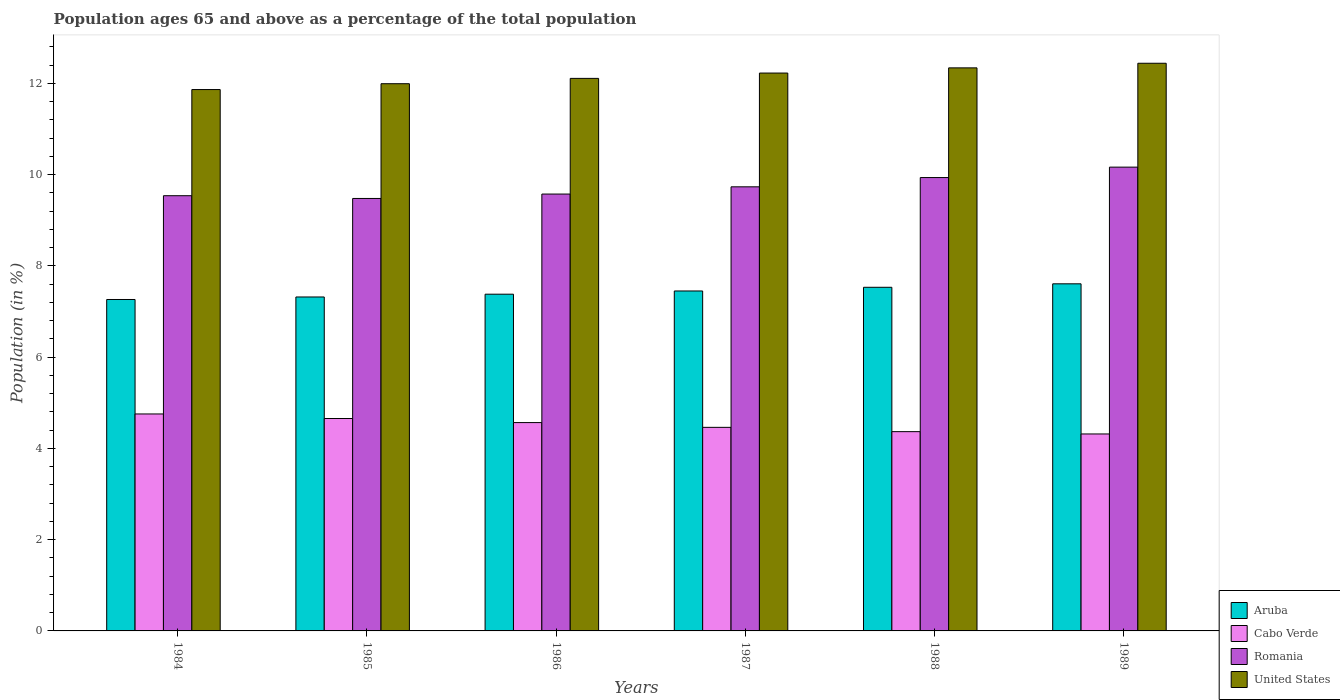How many groups of bars are there?
Your answer should be very brief. 6. Are the number of bars per tick equal to the number of legend labels?
Your answer should be very brief. Yes. What is the label of the 1st group of bars from the left?
Ensure brevity in your answer.  1984. What is the percentage of the population ages 65 and above in Romania in 1989?
Give a very brief answer. 10.16. Across all years, what is the maximum percentage of the population ages 65 and above in Romania?
Your answer should be compact. 10.16. Across all years, what is the minimum percentage of the population ages 65 and above in Aruba?
Offer a very short reply. 7.26. In which year was the percentage of the population ages 65 and above in United States maximum?
Ensure brevity in your answer.  1989. What is the total percentage of the population ages 65 and above in Cabo Verde in the graph?
Provide a short and direct response. 27.12. What is the difference between the percentage of the population ages 65 and above in Aruba in 1987 and that in 1988?
Your answer should be very brief. -0.08. What is the difference between the percentage of the population ages 65 and above in United States in 1986 and the percentage of the population ages 65 and above in Romania in 1985?
Keep it short and to the point. 2.63. What is the average percentage of the population ages 65 and above in Romania per year?
Your answer should be compact. 9.74. In the year 1989, what is the difference between the percentage of the population ages 65 and above in Aruba and percentage of the population ages 65 and above in Romania?
Give a very brief answer. -2.56. What is the ratio of the percentage of the population ages 65 and above in Cabo Verde in 1985 to that in 1986?
Give a very brief answer. 1.02. Is the percentage of the population ages 65 and above in Aruba in 1984 less than that in 1986?
Provide a short and direct response. Yes. Is the difference between the percentage of the population ages 65 and above in Aruba in 1988 and 1989 greater than the difference between the percentage of the population ages 65 and above in Romania in 1988 and 1989?
Keep it short and to the point. Yes. What is the difference between the highest and the second highest percentage of the population ages 65 and above in Cabo Verde?
Keep it short and to the point. 0.1. What is the difference between the highest and the lowest percentage of the population ages 65 and above in Cabo Verde?
Keep it short and to the point. 0.44. In how many years, is the percentage of the population ages 65 and above in Romania greater than the average percentage of the population ages 65 and above in Romania taken over all years?
Your response must be concise. 2. Is the sum of the percentage of the population ages 65 and above in Aruba in 1984 and 1987 greater than the maximum percentage of the population ages 65 and above in Cabo Verde across all years?
Offer a very short reply. Yes. What does the 2nd bar from the left in 1988 represents?
Your answer should be very brief. Cabo Verde. What does the 2nd bar from the right in 1985 represents?
Keep it short and to the point. Romania. How many bars are there?
Keep it short and to the point. 24. Are all the bars in the graph horizontal?
Make the answer very short. No. What is the difference between two consecutive major ticks on the Y-axis?
Ensure brevity in your answer.  2. Does the graph contain any zero values?
Give a very brief answer. No. What is the title of the graph?
Make the answer very short. Population ages 65 and above as a percentage of the total population. Does "Germany" appear as one of the legend labels in the graph?
Give a very brief answer. No. What is the Population (in %) in Aruba in 1984?
Make the answer very short. 7.26. What is the Population (in %) of Cabo Verde in 1984?
Your response must be concise. 4.75. What is the Population (in %) of Romania in 1984?
Make the answer very short. 9.54. What is the Population (in %) of United States in 1984?
Your answer should be compact. 11.86. What is the Population (in %) in Aruba in 1985?
Offer a very short reply. 7.32. What is the Population (in %) of Cabo Verde in 1985?
Ensure brevity in your answer.  4.65. What is the Population (in %) in Romania in 1985?
Offer a very short reply. 9.48. What is the Population (in %) in United States in 1985?
Offer a terse response. 11.99. What is the Population (in %) in Aruba in 1986?
Your response must be concise. 7.38. What is the Population (in %) of Cabo Verde in 1986?
Ensure brevity in your answer.  4.57. What is the Population (in %) in Romania in 1986?
Keep it short and to the point. 9.57. What is the Population (in %) of United States in 1986?
Make the answer very short. 12.11. What is the Population (in %) in Aruba in 1987?
Provide a short and direct response. 7.45. What is the Population (in %) of Cabo Verde in 1987?
Provide a short and direct response. 4.46. What is the Population (in %) of Romania in 1987?
Provide a succinct answer. 9.73. What is the Population (in %) in United States in 1987?
Offer a terse response. 12.22. What is the Population (in %) in Aruba in 1988?
Offer a very short reply. 7.53. What is the Population (in %) of Cabo Verde in 1988?
Provide a succinct answer. 4.37. What is the Population (in %) of Romania in 1988?
Your answer should be compact. 9.93. What is the Population (in %) in United States in 1988?
Provide a short and direct response. 12.34. What is the Population (in %) in Aruba in 1989?
Offer a terse response. 7.61. What is the Population (in %) in Cabo Verde in 1989?
Give a very brief answer. 4.32. What is the Population (in %) of Romania in 1989?
Give a very brief answer. 10.16. What is the Population (in %) in United States in 1989?
Your answer should be compact. 12.44. Across all years, what is the maximum Population (in %) of Aruba?
Provide a short and direct response. 7.61. Across all years, what is the maximum Population (in %) in Cabo Verde?
Provide a short and direct response. 4.75. Across all years, what is the maximum Population (in %) in Romania?
Your answer should be compact. 10.16. Across all years, what is the maximum Population (in %) in United States?
Your answer should be compact. 12.44. Across all years, what is the minimum Population (in %) in Aruba?
Provide a succinct answer. 7.26. Across all years, what is the minimum Population (in %) in Cabo Verde?
Provide a short and direct response. 4.32. Across all years, what is the minimum Population (in %) of Romania?
Ensure brevity in your answer.  9.48. Across all years, what is the minimum Population (in %) in United States?
Your answer should be very brief. 11.86. What is the total Population (in %) of Aruba in the graph?
Provide a succinct answer. 44.54. What is the total Population (in %) in Cabo Verde in the graph?
Provide a succinct answer. 27.12. What is the total Population (in %) in Romania in the graph?
Provide a short and direct response. 58.41. What is the total Population (in %) in United States in the graph?
Give a very brief answer. 72.96. What is the difference between the Population (in %) of Aruba in 1984 and that in 1985?
Give a very brief answer. -0.06. What is the difference between the Population (in %) of Cabo Verde in 1984 and that in 1985?
Provide a short and direct response. 0.1. What is the difference between the Population (in %) in Romania in 1984 and that in 1985?
Offer a very short reply. 0.06. What is the difference between the Population (in %) of United States in 1984 and that in 1985?
Provide a short and direct response. -0.13. What is the difference between the Population (in %) in Aruba in 1984 and that in 1986?
Make the answer very short. -0.12. What is the difference between the Population (in %) in Cabo Verde in 1984 and that in 1986?
Offer a terse response. 0.19. What is the difference between the Population (in %) in Romania in 1984 and that in 1986?
Ensure brevity in your answer.  -0.04. What is the difference between the Population (in %) in United States in 1984 and that in 1986?
Offer a terse response. -0.24. What is the difference between the Population (in %) in Aruba in 1984 and that in 1987?
Offer a terse response. -0.19. What is the difference between the Population (in %) in Cabo Verde in 1984 and that in 1987?
Offer a terse response. 0.29. What is the difference between the Population (in %) of Romania in 1984 and that in 1987?
Offer a terse response. -0.19. What is the difference between the Population (in %) of United States in 1984 and that in 1987?
Your answer should be compact. -0.36. What is the difference between the Population (in %) of Aruba in 1984 and that in 1988?
Provide a short and direct response. -0.27. What is the difference between the Population (in %) in Cabo Verde in 1984 and that in 1988?
Keep it short and to the point. 0.39. What is the difference between the Population (in %) in Romania in 1984 and that in 1988?
Provide a succinct answer. -0.4. What is the difference between the Population (in %) of United States in 1984 and that in 1988?
Provide a succinct answer. -0.47. What is the difference between the Population (in %) of Aruba in 1984 and that in 1989?
Make the answer very short. -0.34. What is the difference between the Population (in %) of Cabo Verde in 1984 and that in 1989?
Offer a terse response. 0.44. What is the difference between the Population (in %) in Romania in 1984 and that in 1989?
Give a very brief answer. -0.63. What is the difference between the Population (in %) of United States in 1984 and that in 1989?
Offer a very short reply. -0.58. What is the difference between the Population (in %) of Aruba in 1985 and that in 1986?
Your response must be concise. -0.06. What is the difference between the Population (in %) in Cabo Verde in 1985 and that in 1986?
Ensure brevity in your answer.  0.09. What is the difference between the Population (in %) in Romania in 1985 and that in 1986?
Offer a very short reply. -0.1. What is the difference between the Population (in %) in United States in 1985 and that in 1986?
Make the answer very short. -0.12. What is the difference between the Population (in %) in Aruba in 1985 and that in 1987?
Your answer should be compact. -0.13. What is the difference between the Population (in %) of Cabo Verde in 1985 and that in 1987?
Your answer should be very brief. 0.19. What is the difference between the Population (in %) in Romania in 1985 and that in 1987?
Your answer should be very brief. -0.25. What is the difference between the Population (in %) of United States in 1985 and that in 1987?
Offer a very short reply. -0.23. What is the difference between the Population (in %) of Aruba in 1985 and that in 1988?
Provide a succinct answer. -0.21. What is the difference between the Population (in %) in Cabo Verde in 1985 and that in 1988?
Your answer should be very brief. 0.29. What is the difference between the Population (in %) in Romania in 1985 and that in 1988?
Provide a succinct answer. -0.46. What is the difference between the Population (in %) of United States in 1985 and that in 1988?
Make the answer very short. -0.35. What is the difference between the Population (in %) in Aruba in 1985 and that in 1989?
Offer a very short reply. -0.29. What is the difference between the Population (in %) of Cabo Verde in 1985 and that in 1989?
Your answer should be very brief. 0.34. What is the difference between the Population (in %) of Romania in 1985 and that in 1989?
Ensure brevity in your answer.  -0.69. What is the difference between the Population (in %) of United States in 1985 and that in 1989?
Your answer should be compact. -0.45. What is the difference between the Population (in %) in Aruba in 1986 and that in 1987?
Provide a short and direct response. -0.07. What is the difference between the Population (in %) in Cabo Verde in 1986 and that in 1987?
Offer a very short reply. 0.1. What is the difference between the Population (in %) in Romania in 1986 and that in 1987?
Keep it short and to the point. -0.16. What is the difference between the Population (in %) of United States in 1986 and that in 1987?
Provide a short and direct response. -0.12. What is the difference between the Population (in %) in Aruba in 1986 and that in 1988?
Provide a succinct answer. -0.15. What is the difference between the Population (in %) in Cabo Verde in 1986 and that in 1988?
Your response must be concise. 0.2. What is the difference between the Population (in %) of Romania in 1986 and that in 1988?
Offer a terse response. -0.36. What is the difference between the Population (in %) in United States in 1986 and that in 1988?
Offer a very short reply. -0.23. What is the difference between the Population (in %) in Aruba in 1986 and that in 1989?
Give a very brief answer. -0.23. What is the difference between the Population (in %) of Cabo Verde in 1986 and that in 1989?
Provide a short and direct response. 0.25. What is the difference between the Population (in %) in Romania in 1986 and that in 1989?
Make the answer very short. -0.59. What is the difference between the Population (in %) of United States in 1986 and that in 1989?
Your answer should be very brief. -0.33. What is the difference between the Population (in %) of Aruba in 1987 and that in 1988?
Your answer should be very brief. -0.08. What is the difference between the Population (in %) of Cabo Verde in 1987 and that in 1988?
Provide a succinct answer. 0.09. What is the difference between the Population (in %) in Romania in 1987 and that in 1988?
Offer a terse response. -0.2. What is the difference between the Population (in %) in United States in 1987 and that in 1988?
Provide a short and direct response. -0.11. What is the difference between the Population (in %) in Aruba in 1987 and that in 1989?
Make the answer very short. -0.16. What is the difference between the Population (in %) in Cabo Verde in 1987 and that in 1989?
Keep it short and to the point. 0.14. What is the difference between the Population (in %) in Romania in 1987 and that in 1989?
Offer a terse response. -0.43. What is the difference between the Population (in %) in United States in 1987 and that in 1989?
Offer a terse response. -0.21. What is the difference between the Population (in %) of Aruba in 1988 and that in 1989?
Give a very brief answer. -0.08. What is the difference between the Population (in %) in Cabo Verde in 1988 and that in 1989?
Your answer should be very brief. 0.05. What is the difference between the Population (in %) of Romania in 1988 and that in 1989?
Ensure brevity in your answer.  -0.23. What is the difference between the Population (in %) of United States in 1988 and that in 1989?
Your answer should be very brief. -0.1. What is the difference between the Population (in %) in Aruba in 1984 and the Population (in %) in Cabo Verde in 1985?
Your response must be concise. 2.61. What is the difference between the Population (in %) of Aruba in 1984 and the Population (in %) of Romania in 1985?
Give a very brief answer. -2.21. What is the difference between the Population (in %) of Aruba in 1984 and the Population (in %) of United States in 1985?
Offer a terse response. -4.73. What is the difference between the Population (in %) of Cabo Verde in 1984 and the Population (in %) of Romania in 1985?
Ensure brevity in your answer.  -4.72. What is the difference between the Population (in %) in Cabo Verde in 1984 and the Population (in %) in United States in 1985?
Provide a succinct answer. -7.24. What is the difference between the Population (in %) of Romania in 1984 and the Population (in %) of United States in 1985?
Provide a succinct answer. -2.45. What is the difference between the Population (in %) in Aruba in 1984 and the Population (in %) in Cabo Verde in 1986?
Ensure brevity in your answer.  2.7. What is the difference between the Population (in %) of Aruba in 1984 and the Population (in %) of Romania in 1986?
Your answer should be very brief. -2.31. What is the difference between the Population (in %) of Aruba in 1984 and the Population (in %) of United States in 1986?
Offer a very short reply. -4.84. What is the difference between the Population (in %) in Cabo Verde in 1984 and the Population (in %) in Romania in 1986?
Make the answer very short. -4.82. What is the difference between the Population (in %) in Cabo Verde in 1984 and the Population (in %) in United States in 1986?
Ensure brevity in your answer.  -7.35. What is the difference between the Population (in %) of Romania in 1984 and the Population (in %) of United States in 1986?
Make the answer very short. -2.57. What is the difference between the Population (in %) in Aruba in 1984 and the Population (in %) in Cabo Verde in 1987?
Ensure brevity in your answer.  2.8. What is the difference between the Population (in %) in Aruba in 1984 and the Population (in %) in Romania in 1987?
Give a very brief answer. -2.47. What is the difference between the Population (in %) in Aruba in 1984 and the Population (in %) in United States in 1987?
Ensure brevity in your answer.  -4.96. What is the difference between the Population (in %) of Cabo Verde in 1984 and the Population (in %) of Romania in 1987?
Make the answer very short. -4.98. What is the difference between the Population (in %) in Cabo Verde in 1984 and the Population (in %) in United States in 1987?
Give a very brief answer. -7.47. What is the difference between the Population (in %) in Romania in 1984 and the Population (in %) in United States in 1987?
Give a very brief answer. -2.69. What is the difference between the Population (in %) of Aruba in 1984 and the Population (in %) of Cabo Verde in 1988?
Offer a terse response. 2.9. What is the difference between the Population (in %) of Aruba in 1984 and the Population (in %) of Romania in 1988?
Offer a terse response. -2.67. What is the difference between the Population (in %) in Aruba in 1984 and the Population (in %) in United States in 1988?
Provide a short and direct response. -5.08. What is the difference between the Population (in %) of Cabo Verde in 1984 and the Population (in %) of Romania in 1988?
Make the answer very short. -5.18. What is the difference between the Population (in %) in Cabo Verde in 1984 and the Population (in %) in United States in 1988?
Make the answer very short. -7.58. What is the difference between the Population (in %) of Romania in 1984 and the Population (in %) of United States in 1988?
Provide a short and direct response. -2.8. What is the difference between the Population (in %) in Aruba in 1984 and the Population (in %) in Cabo Verde in 1989?
Offer a terse response. 2.95. What is the difference between the Population (in %) in Aruba in 1984 and the Population (in %) in Romania in 1989?
Ensure brevity in your answer.  -2.9. What is the difference between the Population (in %) of Aruba in 1984 and the Population (in %) of United States in 1989?
Give a very brief answer. -5.18. What is the difference between the Population (in %) in Cabo Verde in 1984 and the Population (in %) in Romania in 1989?
Ensure brevity in your answer.  -5.41. What is the difference between the Population (in %) in Cabo Verde in 1984 and the Population (in %) in United States in 1989?
Your answer should be compact. -7.68. What is the difference between the Population (in %) of Romania in 1984 and the Population (in %) of United States in 1989?
Your response must be concise. -2.9. What is the difference between the Population (in %) of Aruba in 1985 and the Population (in %) of Cabo Verde in 1986?
Provide a succinct answer. 2.75. What is the difference between the Population (in %) of Aruba in 1985 and the Population (in %) of Romania in 1986?
Keep it short and to the point. -2.26. What is the difference between the Population (in %) of Aruba in 1985 and the Population (in %) of United States in 1986?
Your answer should be compact. -4.79. What is the difference between the Population (in %) of Cabo Verde in 1985 and the Population (in %) of Romania in 1986?
Offer a terse response. -4.92. What is the difference between the Population (in %) in Cabo Verde in 1985 and the Population (in %) in United States in 1986?
Keep it short and to the point. -7.45. What is the difference between the Population (in %) of Romania in 1985 and the Population (in %) of United States in 1986?
Provide a short and direct response. -2.63. What is the difference between the Population (in %) in Aruba in 1985 and the Population (in %) in Cabo Verde in 1987?
Provide a short and direct response. 2.86. What is the difference between the Population (in %) in Aruba in 1985 and the Population (in %) in Romania in 1987?
Give a very brief answer. -2.41. What is the difference between the Population (in %) of Aruba in 1985 and the Population (in %) of United States in 1987?
Provide a short and direct response. -4.91. What is the difference between the Population (in %) of Cabo Verde in 1985 and the Population (in %) of Romania in 1987?
Your answer should be compact. -5.08. What is the difference between the Population (in %) in Cabo Verde in 1985 and the Population (in %) in United States in 1987?
Provide a short and direct response. -7.57. What is the difference between the Population (in %) of Romania in 1985 and the Population (in %) of United States in 1987?
Keep it short and to the point. -2.75. What is the difference between the Population (in %) in Aruba in 1985 and the Population (in %) in Cabo Verde in 1988?
Give a very brief answer. 2.95. What is the difference between the Population (in %) in Aruba in 1985 and the Population (in %) in Romania in 1988?
Keep it short and to the point. -2.62. What is the difference between the Population (in %) of Aruba in 1985 and the Population (in %) of United States in 1988?
Offer a terse response. -5.02. What is the difference between the Population (in %) of Cabo Verde in 1985 and the Population (in %) of Romania in 1988?
Your answer should be compact. -5.28. What is the difference between the Population (in %) in Cabo Verde in 1985 and the Population (in %) in United States in 1988?
Ensure brevity in your answer.  -7.68. What is the difference between the Population (in %) of Romania in 1985 and the Population (in %) of United States in 1988?
Your answer should be compact. -2.86. What is the difference between the Population (in %) in Aruba in 1985 and the Population (in %) in Cabo Verde in 1989?
Offer a very short reply. 3. What is the difference between the Population (in %) of Aruba in 1985 and the Population (in %) of Romania in 1989?
Give a very brief answer. -2.85. What is the difference between the Population (in %) of Aruba in 1985 and the Population (in %) of United States in 1989?
Keep it short and to the point. -5.12. What is the difference between the Population (in %) in Cabo Verde in 1985 and the Population (in %) in Romania in 1989?
Offer a terse response. -5.51. What is the difference between the Population (in %) of Cabo Verde in 1985 and the Population (in %) of United States in 1989?
Make the answer very short. -7.78. What is the difference between the Population (in %) of Romania in 1985 and the Population (in %) of United States in 1989?
Offer a terse response. -2.96. What is the difference between the Population (in %) of Aruba in 1986 and the Population (in %) of Cabo Verde in 1987?
Your answer should be compact. 2.92. What is the difference between the Population (in %) in Aruba in 1986 and the Population (in %) in Romania in 1987?
Offer a very short reply. -2.35. What is the difference between the Population (in %) in Aruba in 1986 and the Population (in %) in United States in 1987?
Give a very brief answer. -4.85. What is the difference between the Population (in %) in Cabo Verde in 1986 and the Population (in %) in Romania in 1987?
Ensure brevity in your answer.  -5.17. What is the difference between the Population (in %) of Cabo Verde in 1986 and the Population (in %) of United States in 1987?
Make the answer very short. -7.66. What is the difference between the Population (in %) of Romania in 1986 and the Population (in %) of United States in 1987?
Offer a very short reply. -2.65. What is the difference between the Population (in %) in Aruba in 1986 and the Population (in %) in Cabo Verde in 1988?
Your answer should be very brief. 3.01. What is the difference between the Population (in %) in Aruba in 1986 and the Population (in %) in Romania in 1988?
Provide a short and direct response. -2.56. What is the difference between the Population (in %) of Aruba in 1986 and the Population (in %) of United States in 1988?
Your response must be concise. -4.96. What is the difference between the Population (in %) of Cabo Verde in 1986 and the Population (in %) of Romania in 1988?
Offer a terse response. -5.37. What is the difference between the Population (in %) in Cabo Verde in 1986 and the Population (in %) in United States in 1988?
Offer a terse response. -7.77. What is the difference between the Population (in %) of Romania in 1986 and the Population (in %) of United States in 1988?
Offer a very short reply. -2.76. What is the difference between the Population (in %) of Aruba in 1986 and the Population (in %) of Cabo Verde in 1989?
Ensure brevity in your answer.  3.06. What is the difference between the Population (in %) in Aruba in 1986 and the Population (in %) in Romania in 1989?
Your answer should be very brief. -2.78. What is the difference between the Population (in %) of Aruba in 1986 and the Population (in %) of United States in 1989?
Offer a very short reply. -5.06. What is the difference between the Population (in %) in Cabo Verde in 1986 and the Population (in %) in Romania in 1989?
Offer a very short reply. -5.6. What is the difference between the Population (in %) in Cabo Verde in 1986 and the Population (in %) in United States in 1989?
Your answer should be compact. -7.87. What is the difference between the Population (in %) in Romania in 1986 and the Population (in %) in United States in 1989?
Your answer should be compact. -2.87. What is the difference between the Population (in %) in Aruba in 1987 and the Population (in %) in Cabo Verde in 1988?
Provide a succinct answer. 3.08. What is the difference between the Population (in %) in Aruba in 1987 and the Population (in %) in Romania in 1988?
Your answer should be compact. -2.49. What is the difference between the Population (in %) in Aruba in 1987 and the Population (in %) in United States in 1988?
Your answer should be very brief. -4.89. What is the difference between the Population (in %) of Cabo Verde in 1987 and the Population (in %) of Romania in 1988?
Your answer should be very brief. -5.47. What is the difference between the Population (in %) in Cabo Verde in 1987 and the Population (in %) in United States in 1988?
Provide a succinct answer. -7.88. What is the difference between the Population (in %) of Romania in 1987 and the Population (in %) of United States in 1988?
Ensure brevity in your answer.  -2.61. What is the difference between the Population (in %) of Aruba in 1987 and the Population (in %) of Cabo Verde in 1989?
Your answer should be very brief. 3.13. What is the difference between the Population (in %) in Aruba in 1987 and the Population (in %) in Romania in 1989?
Provide a short and direct response. -2.71. What is the difference between the Population (in %) of Aruba in 1987 and the Population (in %) of United States in 1989?
Your response must be concise. -4.99. What is the difference between the Population (in %) in Cabo Verde in 1987 and the Population (in %) in Romania in 1989?
Offer a very short reply. -5.7. What is the difference between the Population (in %) of Cabo Verde in 1987 and the Population (in %) of United States in 1989?
Make the answer very short. -7.98. What is the difference between the Population (in %) in Romania in 1987 and the Population (in %) in United States in 1989?
Ensure brevity in your answer.  -2.71. What is the difference between the Population (in %) of Aruba in 1988 and the Population (in %) of Cabo Verde in 1989?
Offer a very short reply. 3.21. What is the difference between the Population (in %) in Aruba in 1988 and the Population (in %) in Romania in 1989?
Make the answer very short. -2.63. What is the difference between the Population (in %) in Aruba in 1988 and the Population (in %) in United States in 1989?
Provide a succinct answer. -4.91. What is the difference between the Population (in %) of Cabo Verde in 1988 and the Population (in %) of Romania in 1989?
Offer a very short reply. -5.8. What is the difference between the Population (in %) of Cabo Verde in 1988 and the Population (in %) of United States in 1989?
Your response must be concise. -8.07. What is the difference between the Population (in %) in Romania in 1988 and the Population (in %) in United States in 1989?
Your answer should be very brief. -2.5. What is the average Population (in %) of Aruba per year?
Offer a very short reply. 7.42. What is the average Population (in %) of Cabo Verde per year?
Keep it short and to the point. 4.52. What is the average Population (in %) in Romania per year?
Your answer should be very brief. 9.74. What is the average Population (in %) of United States per year?
Your response must be concise. 12.16. In the year 1984, what is the difference between the Population (in %) in Aruba and Population (in %) in Cabo Verde?
Make the answer very short. 2.51. In the year 1984, what is the difference between the Population (in %) in Aruba and Population (in %) in Romania?
Keep it short and to the point. -2.27. In the year 1984, what is the difference between the Population (in %) of Aruba and Population (in %) of United States?
Your answer should be compact. -4.6. In the year 1984, what is the difference between the Population (in %) of Cabo Verde and Population (in %) of Romania?
Your answer should be compact. -4.78. In the year 1984, what is the difference between the Population (in %) of Cabo Verde and Population (in %) of United States?
Offer a terse response. -7.11. In the year 1984, what is the difference between the Population (in %) in Romania and Population (in %) in United States?
Ensure brevity in your answer.  -2.33. In the year 1985, what is the difference between the Population (in %) of Aruba and Population (in %) of Cabo Verde?
Your response must be concise. 2.66. In the year 1985, what is the difference between the Population (in %) in Aruba and Population (in %) in Romania?
Give a very brief answer. -2.16. In the year 1985, what is the difference between the Population (in %) in Aruba and Population (in %) in United States?
Offer a very short reply. -4.67. In the year 1985, what is the difference between the Population (in %) of Cabo Verde and Population (in %) of Romania?
Give a very brief answer. -4.82. In the year 1985, what is the difference between the Population (in %) in Cabo Verde and Population (in %) in United States?
Offer a very short reply. -7.34. In the year 1985, what is the difference between the Population (in %) of Romania and Population (in %) of United States?
Ensure brevity in your answer.  -2.51. In the year 1986, what is the difference between the Population (in %) in Aruba and Population (in %) in Cabo Verde?
Offer a very short reply. 2.81. In the year 1986, what is the difference between the Population (in %) of Aruba and Population (in %) of Romania?
Offer a very short reply. -2.19. In the year 1986, what is the difference between the Population (in %) in Aruba and Population (in %) in United States?
Provide a short and direct response. -4.73. In the year 1986, what is the difference between the Population (in %) in Cabo Verde and Population (in %) in Romania?
Keep it short and to the point. -5.01. In the year 1986, what is the difference between the Population (in %) in Cabo Verde and Population (in %) in United States?
Keep it short and to the point. -7.54. In the year 1986, what is the difference between the Population (in %) in Romania and Population (in %) in United States?
Your answer should be very brief. -2.53. In the year 1987, what is the difference between the Population (in %) in Aruba and Population (in %) in Cabo Verde?
Keep it short and to the point. 2.99. In the year 1987, what is the difference between the Population (in %) of Aruba and Population (in %) of Romania?
Offer a terse response. -2.28. In the year 1987, what is the difference between the Population (in %) in Aruba and Population (in %) in United States?
Keep it short and to the point. -4.78. In the year 1987, what is the difference between the Population (in %) in Cabo Verde and Population (in %) in Romania?
Make the answer very short. -5.27. In the year 1987, what is the difference between the Population (in %) of Cabo Verde and Population (in %) of United States?
Offer a very short reply. -7.76. In the year 1987, what is the difference between the Population (in %) in Romania and Population (in %) in United States?
Keep it short and to the point. -2.49. In the year 1988, what is the difference between the Population (in %) of Aruba and Population (in %) of Cabo Verde?
Make the answer very short. 3.16. In the year 1988, what is the difference between the Population (in %) in Aruba and Population (in %) in Romania?
Offer a terse response. -2.4. In the year 1988, what is the difference between the Population (in %) in Aruba and Population (in %) in United States?
Your answer should be compact. -4.81. In the year 1988, what is the difference between the Population (in %) of Cabo Verde and Population (in %) of Romania?
Provide a succinct answer. -5.57. In the year 1988, what is the difference between the Population (in %) in Cabo Verde and Population (in %) in United States?
Ensure brevity in your answer.  -7.97. In the year 1988, what is the difference between the Population (in %) of Romania and Population (in %) of United States?
Your answer should be compact. -2.4. In the year 1989, what is the difference between the Population (in %) in Aruba and Population (in %) in Cabo Verde?
Ensure brevity in your answer.  3.29. In the year 1989, what is the difference between the Population (in %) of Aruba and Population (in %) of Romania?
Your response must be concise. -2.56. In the year 1989, what is the difference between the Population (in %) in Aruba and Population (in %) in United States?
Your answer should be very brief. -4.83. In the year 1989, what is the difference between the Population (in %) in Cabo Verde and Population (in %) in Romania?
Ensure brevity in your answer.  -5.85. In the year 1989, what is the difference between the Population (in %) of Cabo Verde and Population (in %) of United States?
Ensure brevity in your answer.  -8.12. In the year 1989, what is the difference between the Population (in %) in Romania and Population (in %) in United States?
Ensure brevity in your answer.  -2.28. What is the ratio of the Population (in %) in Aruba in 1984 to that in 1985?
Your answer should be compact. 0.99. What is the ratio of the Population (in %) in Cabo Verde in 1984 to that in 1985?
Offer a very short reply. 1.02. What is the ratio of the Population (in %) of Romania in 1984 to that in 1985?
Provide a succinct answer. 1.01. What is the ratio of the Population (in %) of United States in 1984 to that in 1985?
Your response must be concise. 0.99. What is the ratio of the Population (in %) in Aruba in 1984 to that in 1986?
Provide a succinct answer. 0.98. What is the ratio of the Population (in %) in Cabo Verde in 1984 to that in 1986?
Offer a very short reply. 1.04. What is the ratio of the Population (in %) of United States in 1984 to that in 1986?
Keep it short and to the point. 0.98. What is the ratio of the Population (in %) of Cabo Verde in 1984 to that in 1987?
Provide a succinct answer. 1.07. What is the ratio of the Population (in %) in United States in 1984 to that in 1987?
Provide a short and direct response. 0.97. What is the ratio of the Population (in %) in Aruba in 1984 to that in 1988?
Give a very brief answer. 0.96. What is the ratio of the Population (in %) in Cabo Verde in 1984 to that in 1988?
Make the answer very short. 1.09. What is the ratio of the Population (in %) in United States in 1984 to that in 1988?
Your answer should be very brief. 0.96. What is the ratio of the Population (in %) of Aruba in 1984 to that in 1989?
Your answer should be very brief. 0.95. What is the ratio of the Population (in %) of Cabo Verde in 1984 to that in 1989?
Your answer should be very brief. 1.1. What is the ratio of the Population (in %) in Romania in 1984 to that in 1989?
Your answer should be very brief. 0.94. What is the ratio of the Population (in %) in United States in 1984 to that in 1989?
Your answer should be compact. 0.95. What is the ratio of the Population (in %) of Aruba in 1985 to that in 1986?
Offer a very short reply. 0.99. What is the ratio of the Population (in %) in Cabo Verde in 1985 to that in 1986?
Give a very brief answer. 1.02. What is the ratio of the Population (in %) of Aruba in 1985 to that in 1987?
Provide a short and direct response. 0.98. What is the ratio of the Population (in %) in Cabo Verde in 1985 to that in 1987?
Your response must be concise. 1.04. What is the ratio of the Population (in %) in Romania in 1985 to that in 1987?
Provide a succinct answer. 0.97. What is the ratio of the Population (in %) of United States in 1985 to that in 1987?
Ensure brevity in your answer.  0.98. What is the ratio of the Population (in %) in Aruba in 1985 to that in 1988?
Provide a short and direct response. 0.97. What is the ratio of the Population (in %) in Cabo Verde in 1985 to that in 1988?
Your answer should be very brief. 1.07. What is the ratio of the Population (in %) in Romania in 1985 to that in 1988?
Your answer should be very brief. 0.95. What is the ratio of the Population (in %) of United States in 1985 to that in 1988?
Offer a terse response. 0.97. What is the ratio of the Population (in %) in Aruba in 1985 to that in 1989?
Offer a very short reply. 0.96. What is the ratio of the Population (in %) of Cabo Verde in 1985 to that in 1989?
Give a very brief answer. 1.08. What is the ratio of the Population (in %) in Romania in 1985 to that in 1989?
Your response must be concise. 0.93. What is the ratio of the Population (in %) of Aruba in 1986 to that in 1987?
Offer a very short reply. 0.99. What is the ratio of the Population (in %) of Cabo Verde in 1986 to that in 1987?
Ensure brevity in your answer.  1.02. What is the ratio of the Population (in %) of Romania in 1986 to that in 1987?
Offer a terse response. 0.98. What is the ratio of the Population (in %) in Aruba in 1986 to that in 1988?
Your answer should be very brief. 0.98. What is the ratio of the Population (in %) in Cabo Verde in 1986 to that in 1988?
Give a very brief answer. 1.05. What is the ratio of the Population (in %) in Romania in 1986 to that in 1988?
Offer a very short reply. 0.96. What is the ratio of the Population (in %) of United States in 1986 to that in 1988?
Offer a terse response. 0.98. What is the ratio of the Population (in %) in Aruba in 1986 to that in 1989?
Your answer should be compact. 0.97. What is the ratio of the Population (in %) of Cabo Verde in 1986 to that in 1989?
Your answer should be very brief. 1.06. What is the ratio of the Population (in %) of Romania in 1986 to that in 1989?
Give a very brief answer. 0.94. What is the ratio of the Population (in %) of United States in 1986 to that in 1989?
Keep it short and to the point. 0.97. What is the ratio of the Population (in %) in Cabo Verde in 1987 to that in 1988?
Give a very brief answer. 1.02. What is the ratio of the Population (in %) of Romania in 1987 to that in 1988?
Offer a terse response. 0.98. What is the ratio of the Population (in %) of United States in 1987 to that in 1988?
Your answer should be compact. 0.99. What is the ratio of the Population (in %) in Aruba in 1987 to that in 1989?
Provide a short and direct response. 0.98. What is the ratio of the Population (in %) of Cabo Verde in 1987 to that in 1989?
Offer a very short reply. 1.03. What is the ratio of the Population (in %) in Romania in 1987 to that in 1989?
Keep it short and to the point. 0.96. What is the ratio of the Population (in %) in United States in 1987 to that in 1989?
Your answer should be compact. 0.98. What is the ratio of the Population (in %) of Aruba in 1988 to that in 1989?
Make the answer very short. 0.99. What is the ratio of the Population (in %) in Cabo Verde in 1988 to that in 1989?
Provide a short and direct response. 1.01. What is the ratio of the Population (in %) in Romania in 1988 to that in 1989?
Keep it short and to the point. 0.98. What is the difference between the highest and the second highest Population (in %) of Aruba?
Offer a very short reply. 0.08. What is the difference between the highest and the second highest Population (in %) of Cabo Verde?
Keep it short and to the point. 0.1. What is the difference between the highest and the second highest Population (in %) in Romania?
Offer a very short reply. 0.23. What is the difference between the highest and the second highest Population (in %) of United States?
Make the answer very short. 0.1. What is the difference between the highest and the lowest Population (in %) of Aruba?
Your answer should be compact. 0.34. What is the difference between the highest and the lowest Population (in %) of Cabo Verde?
Your response must be concise. 0.44. What is the difference between the highest and the lowest Population (in %) in Romania?
Ensure brevity in your answer.  0.69. What is the difference between the highest and the lowest Population (in %) in United States?
Provide a short and direct response. 0.58. 